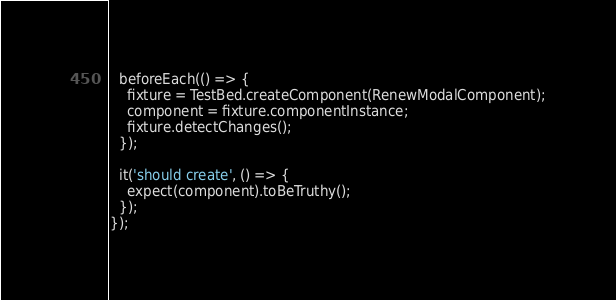<code> <loc_0><loc_0><loc_500><loc_500><_TypeScript_>
  beforeEach(() => {
    fixture = TestBed.createComponent(RenewModalComponent);
    component = fixture.componentInstance;
    fixture.detectChanges();
  });

  it('should create', () => {
    expect(component).toBeTruthy();
  });
});
</code> 